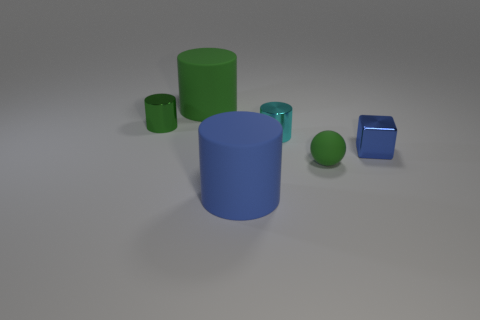How many tiny cubes are the same material as the small green cylinder?
Keep it short and to the point. 1. Is the shape of the large rubber object that is in front of the large green rubber object the same as  the blue metal object?
Keep it short and to the point. No. There is a big cylinder that is the same material as the large green object; what color is it?
Provide a short and direct response. Blue. There is a matte object that is in front of the green sphere in front of the small green metal object; is there a green metallic object that is in front of it?
Provide a short and direct response. No. What shape is the small cyan object?
Offer a terse response. Cylinder. Is the number of metallic objects on the left side of the tiny green cylinder less than the number of big yellow shiny things?
Keep it short and to the point. No. Is there another thing that has the same shape as the blue shiny thing?
Provide a short and direct response. No. The blue object that is the same size as the matte ball is what shape?
Keep it short and to the point. Cube. How many things are large purple cubes or green metallic cylinders?
Ensure brevity in your answer.  1. Are any big rubber objects visible?
Your answer should be compact. Yes. 